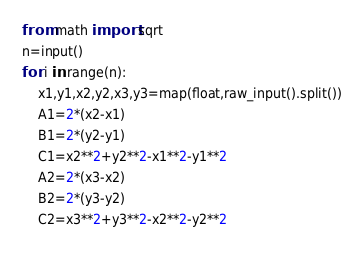Convert code to text. <code><loc_0><loc_0><loc_500><loc_500><_Python_>from math import sqrt
n=input()
for i in range(n):
	x1,y1,x2,y2,x3,y3=map(float,raw_input().split())
	A1=2*(x2-x1)
	B1=2*(y2-y1)
	C1=x2**2+y2**2-x1**2-y1**2
	A2=2*(x3-x2)
    B2=2*(y3-y2)
    C2=x3**2+y3**2-x2**2-y2**2</code> 